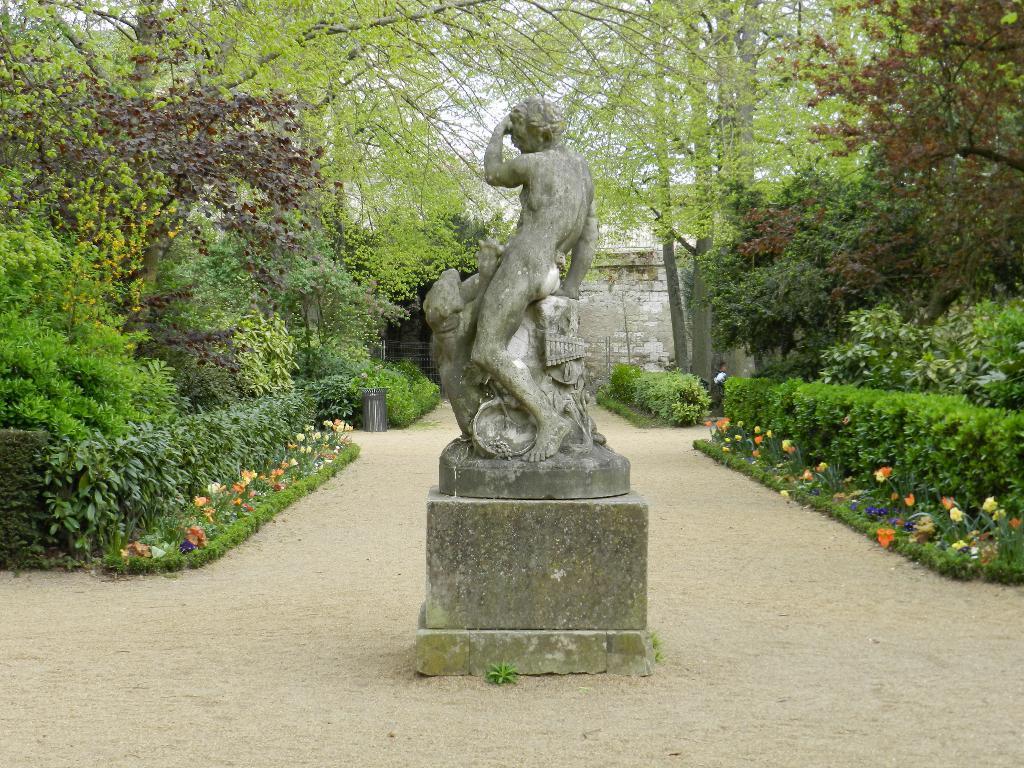Could you give a brief overview of what you see in this image? This image consists of a statue in the middle. There are bushes in the middle. There are trees at the top. 